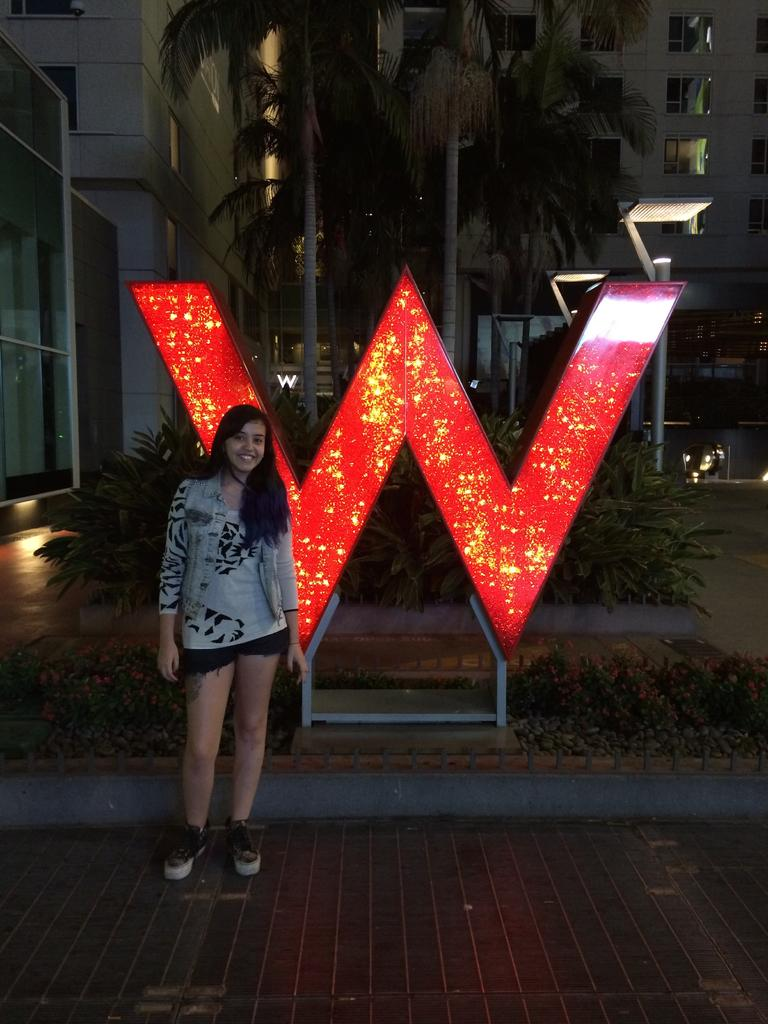What is the woman in the image doing? The woman is standing on a path and smiling. What can be seen in the background of the image? There is an alphabet monument, plants, trees, buildings, and lights visible in the image. What type of pot is being used to cook the food in the image? There is no pot or food visible in the image. Can you see a bat flying in the sky in the image? There is no bat visible in the image. 